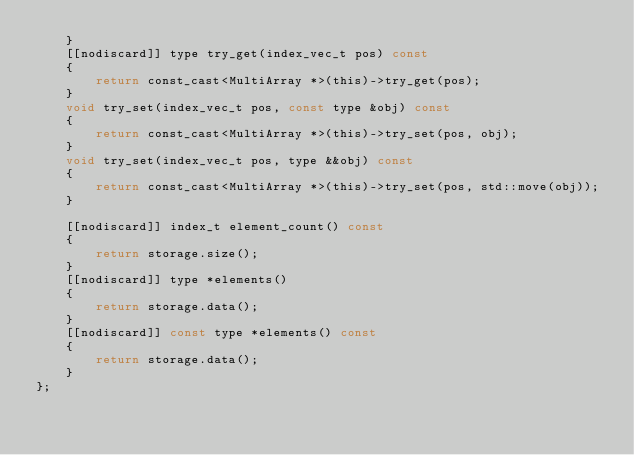<code> <loc_0><loc_0><loc_500><loc_500><_C_>    }
    [[nodiscard]] type try_get(index_vec_t pos) const
    {
        return const_cast<MultiArray *>(this)->try_get(pos);
    }
    void try_set(index_vec_t pos, const type &obj) const
    {
        return const_cast<MultiArray *>(this)->try_set(pos, obj);
    }
    void try_set(index_vec_t pos, type &&obj) const
    {
        return const_cast<MultiArray *>(this)->try_set(pos, std::move(obj));
    }

    [[nodiscard]] index_t element_count() const
    {
        return storage.size();
    }
    [[nodiscard]] type *elements()
    {
        return storage.data();
    }
    [[nodiscard]] const type *elements() const
    {
        return storage.data();
    }
};
</code> 